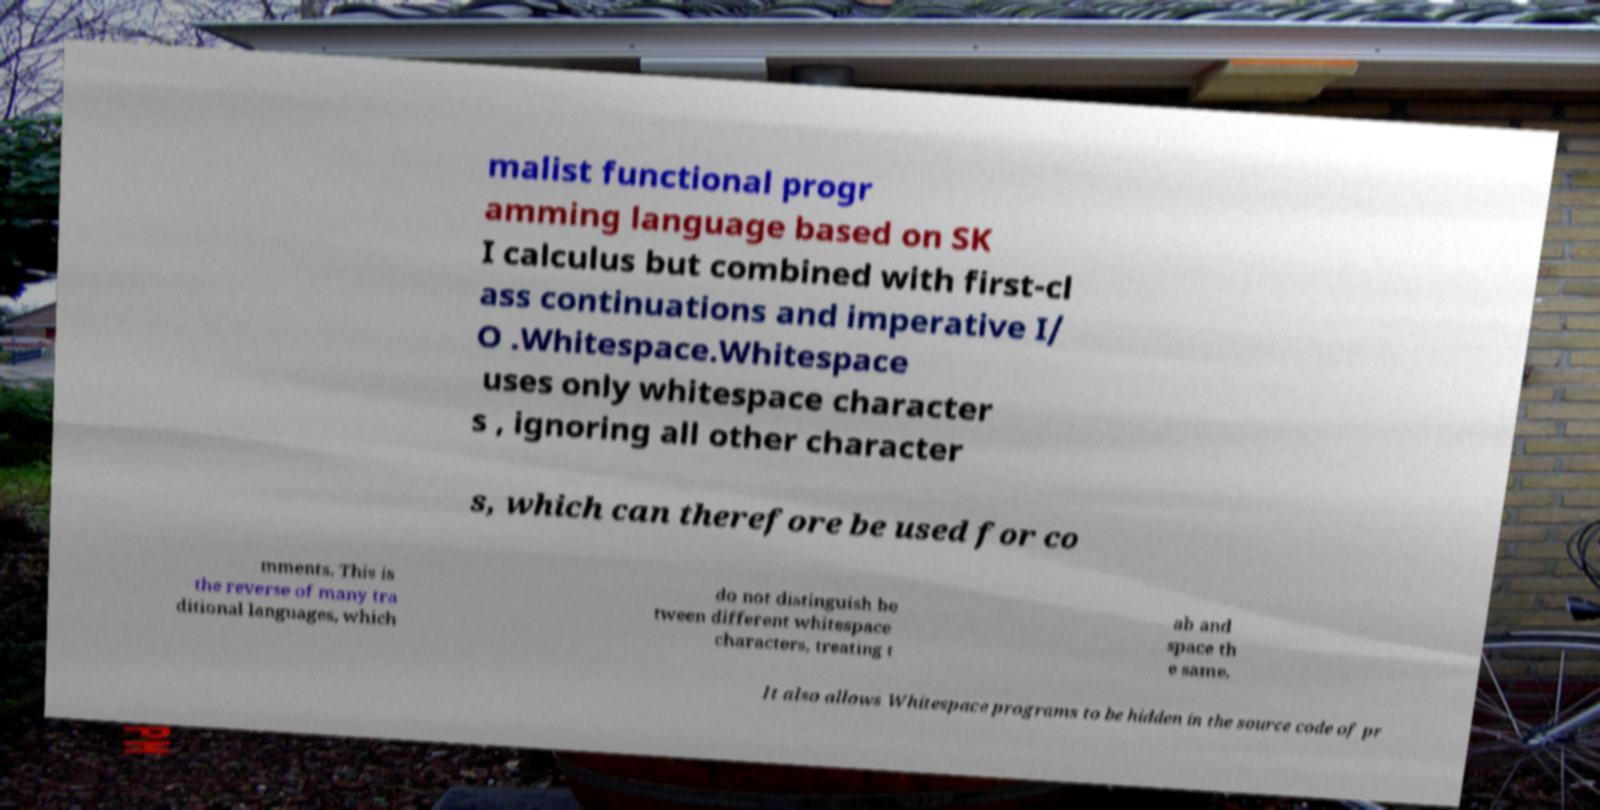Please identify and transcribe the text found in this image. malist functional progr amming language based on SK I calculus but combined with first-cl ass continuations and imperative I/ O .Whitespace.Whitespace uses only whitespace character s , ignoring all other character s, which can therefore be used for co mments. This is the reverse of many tra ditional languages, which do not distinguish be tween different whitespace characters, treating t ab and space th e same. It also allows Whitespace programs to be hidden in the source code of pr 